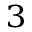<formula> <loc_0><loc_0><loc_500><loc_500>_ { 3 }</formula> 